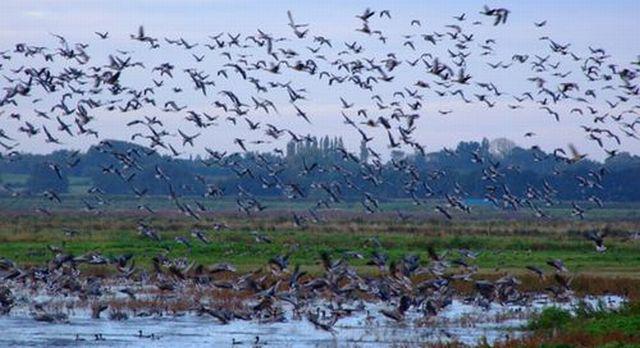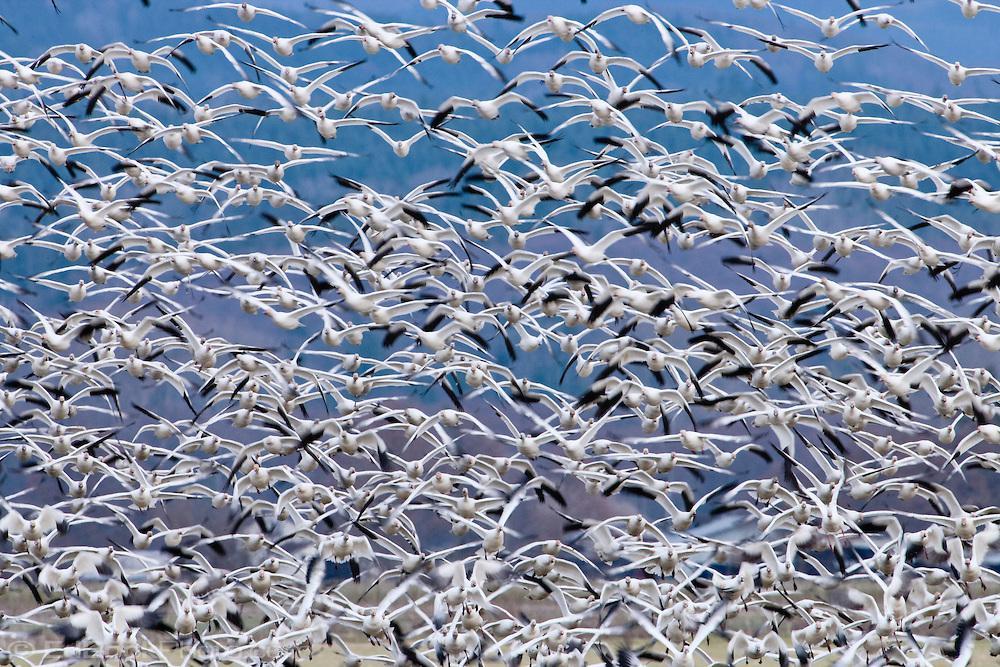The first image is the image on the left, the second image is the image on the right. Considering the images on both sides, is "The left image includes a body of water with some birds in the water." valid? Answer yes or no. Yes. The first image is the image on the left, the second image is the image on the right. For the images displayed, is the sentence "There are at least 100 white bird sitting on the ground with at least 2 gray crane walking across the field." factually correct? Answer yes or no. No. 